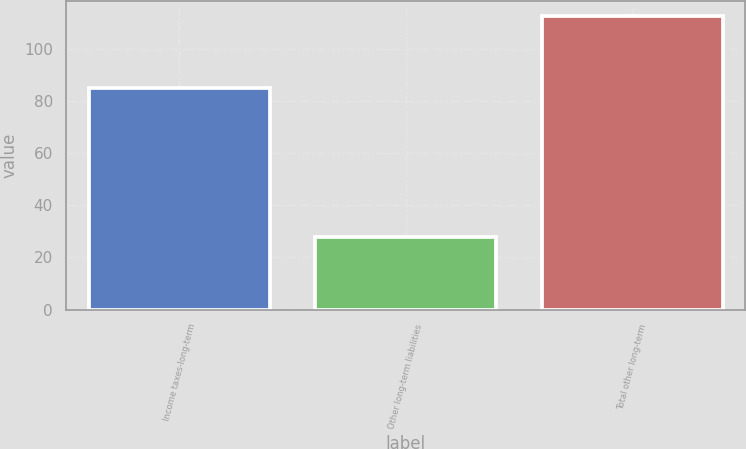<chart> <loc_0><loc_0><loc_500><loc_500><bar_chart><fcel>Income taxes-long-term<fcel>Other long-term liabilities<fcel>Total other long-term<nl><fcel>84.9<fcel>27.7<fcel>112.6<nl></chart> 